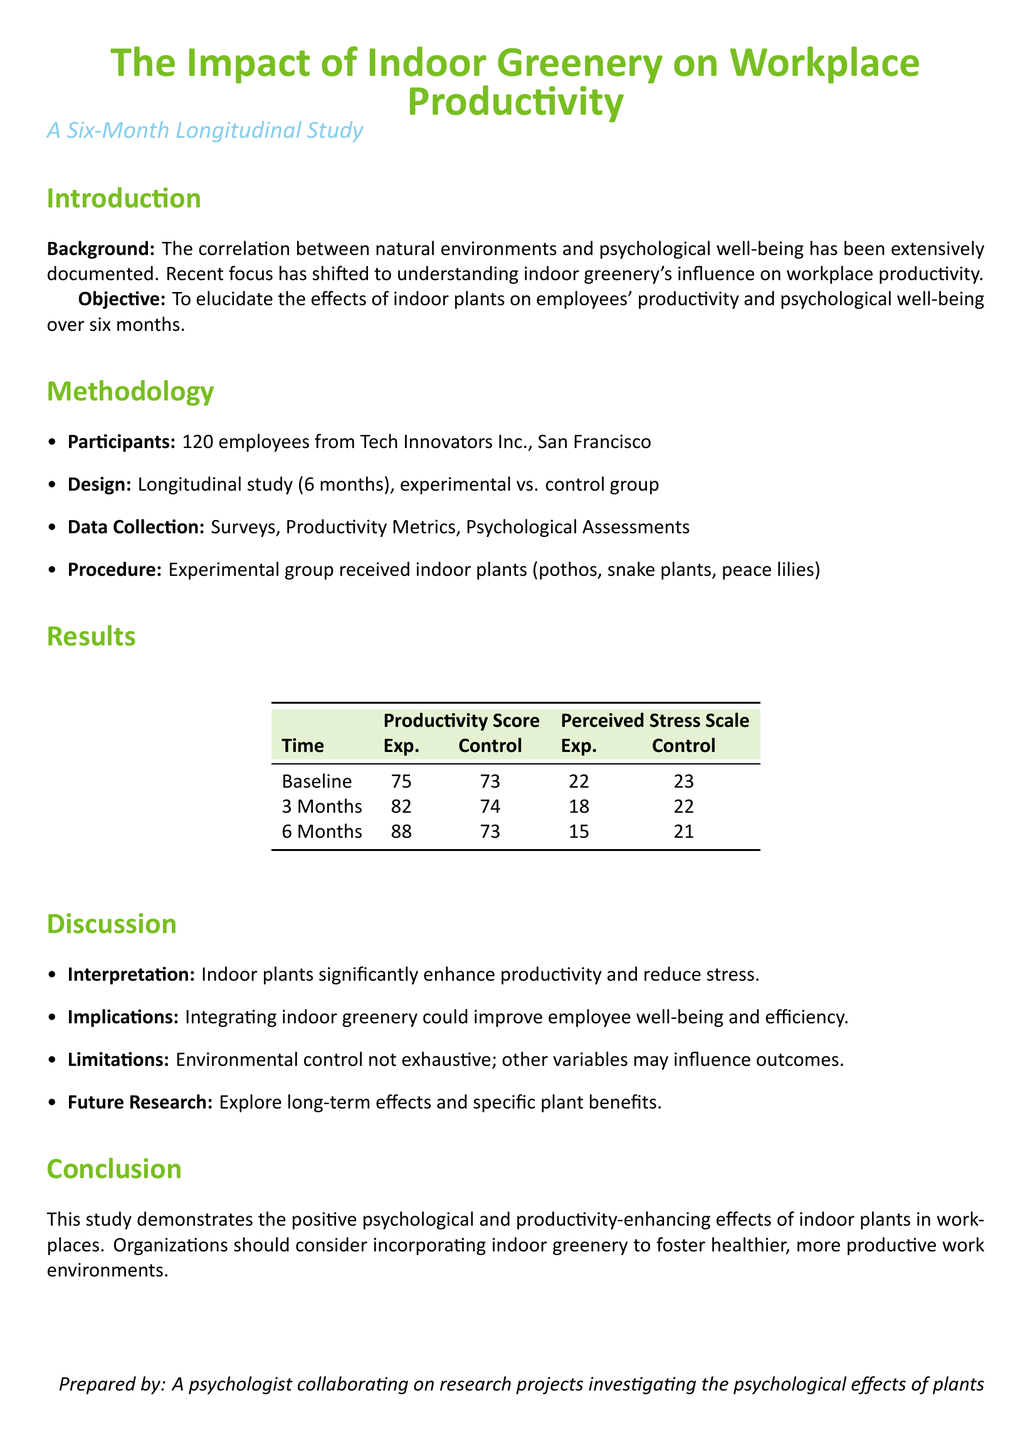What is the sample size of the study? The sample size is provided in the methodology section of the document as 120 employees.
Answer: 120 employees What types of indoor plants were used in the experimental group? The experimental group received specific types of plants, as mentioned in the methodology section.
Answer: Pothos, snake plants, peace lilies What was the productivity score for the experimental group at the 6-month mark? The productivity score for the experimental group at the 6-month mark is listed in the results table.
Answer: 88 What was the perceived stress score for the control group at baseline? The perceived stress score for the control group is found in the results table under baseline.
Answer: 23 What is one implication of integrating indoor greenery mentioned in the discussion? The implications of integrating indoor greenery are summarized in the discussion section.
Answer: Improve employee well-being What was the perceived stress score for the experimental group after 3 months? The stress score for the experimental group at the 3-month interval is specified in the results.
Answer: 18 What was the focus of the study? The focus is described in the objective section regarding the effects of indoor plants.
Answer: Effects of indoor plants on employees' productivity What type of study design was used in this research? The design type is explained in the methodology section of the document.
Answer: Longitudinal study What does the study recommend for organizations? The conclusion provides recommendations for organizations regarding workplace environments.
Answer: Incorporating indoor greenery 